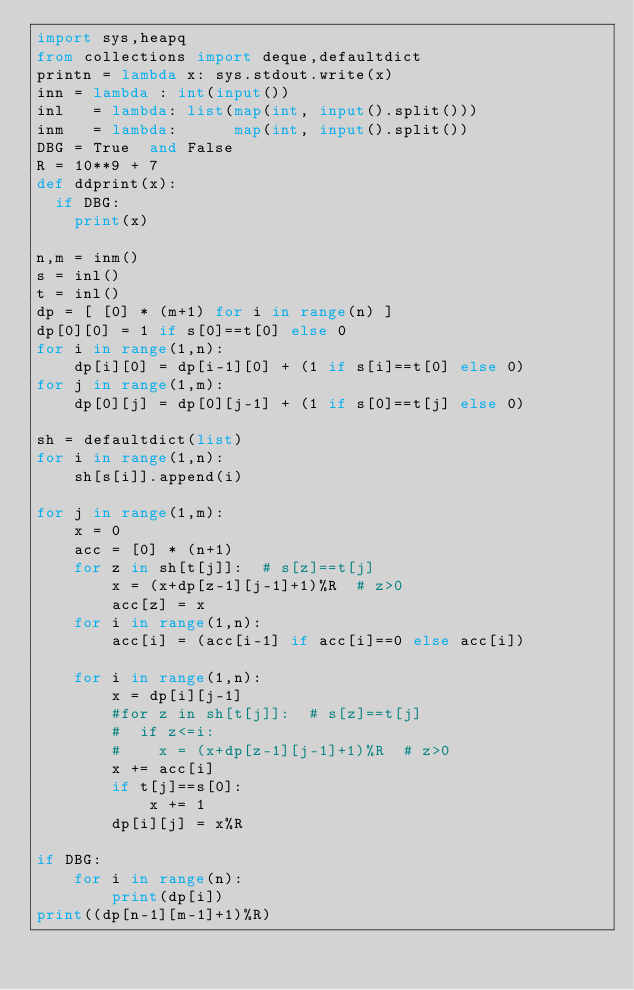Convert code to text. <code><loc_0><loc_0><loc_500><loc_500><_Python_>import sys,heapq
from collections import deque,defaultdict
printn = lambda x: sys.stdout.write(x)
inn = lambda : int(input())
inl   = lambda: list(map(int, input().split()))
inm   = lambda:      map(int, input().split())
DBG = True  and False
R = 10**9 + 7
def ddprint(x):
  if DBG:
    print(x)

n,m = inm()
s = inl()
t = inl()
dp = [ [0] * (m+1) for i in range(n) ]
dp[0][0] = 1 if s[0]==t[0] else 0
for i in range(1,n):
    dp[i][0] = dp[i-1][0] + (1 if s[i]==t[0] else 0)
for j in range(1,m):
    dp[0][j] = dp[0][j-1] + (1 if s[0]==t[j] else 0)

sh = defaultdict(list)
for i in range(1,n):
    sh[s[i]].append(i)

for j in range(1,m):
    x = 0
    acc = [0] * (n+1)
    for z in sh[t[j]]:  # s[z]==t[j]
        x = (x+dp[z-1][j-1]+1)%R  # z>0
        acc[z] = x
    for i in range(1,n):
        acc[i] = (acc[i-1] if acc[i]==0 else acc[i])

    for i in range(1,n):
        x = dp[i][j-1]
        #for z in sh[t[j]]:  # s[z]==t[j]
        #  if z<=i:
        #    x = (x+dp[z-1][j-1]+1)%R  # z>0
        x += acc[i]
        if t[j]==s[0]:
            x += 1
        dp[i][j] = x%R

if DBG:
    for i in range(n):
        print(dp[i])
print((dp[n-1][m-1]+1)%R)
</code> 